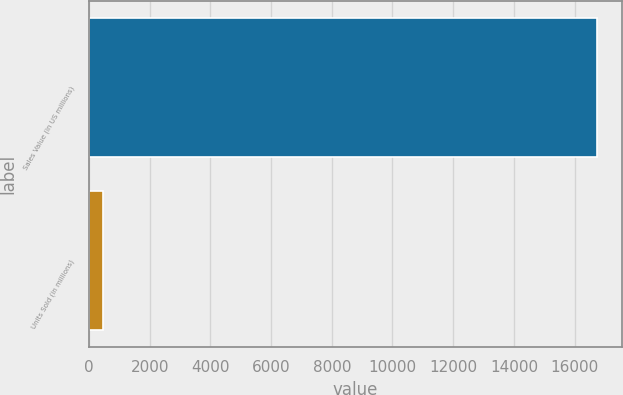<chart> <loc_0><loc_0><loc_500><loc_500><bar_chart><fcel>Sales Value (in US millions)<fcel>Units Sold (in millions)<nl><fcel>16727<fcel>462.6<nl></chart> 